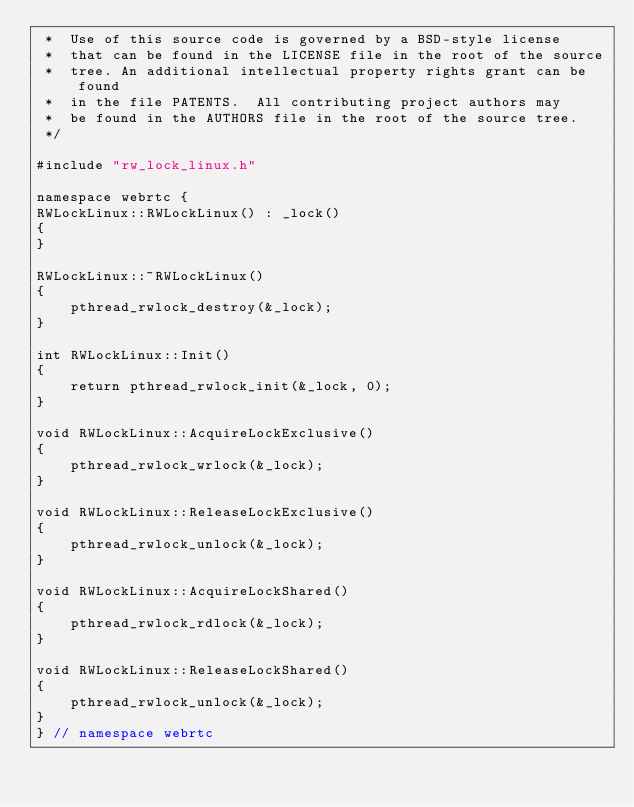<code> <loc_0><loc_0><loc_500><loc_500><_C++_> *  Use of this source code is governed by a BSD-style license
 *  that can be found in the LICENSE file in the root of the source
 *  tree. An additional intellectual property rights grant can be found
 *  in the file PATENTS.  All contributing project authors may
 *  be found in the AUTHORS file in the root of the source tree.
 */

#include "rw_lock_linux.h"

namespace webrtc {
RWLockLinux::RWLockLinux() : _lock()
{
}

RWLockLinux::~RWLockLinux()
{
    pthread_rwlock_destroy(&_lock);
}

int RWLockLinux::Init()
{
    return pthread_rwlock_init(&_lock, 0);
}

void RWLockLinux::AcquireLockExclusive()
{
    pthread_rwlock_wrlock(&_lock);
}

void RWLockLinux::ReleaseLockExclusive()
{
    pthread_rwlock_unlock(&_lock);
}

void RWLockLinux::AcquireLockShared()
{
    pthread_rwlock_rdlock(&_lock);
}

void RWLockLinux::ReleaseLockShared()
{
    pthread_rwlock_unlock(&_lock);
}
} // namespace webrtc
</code> 